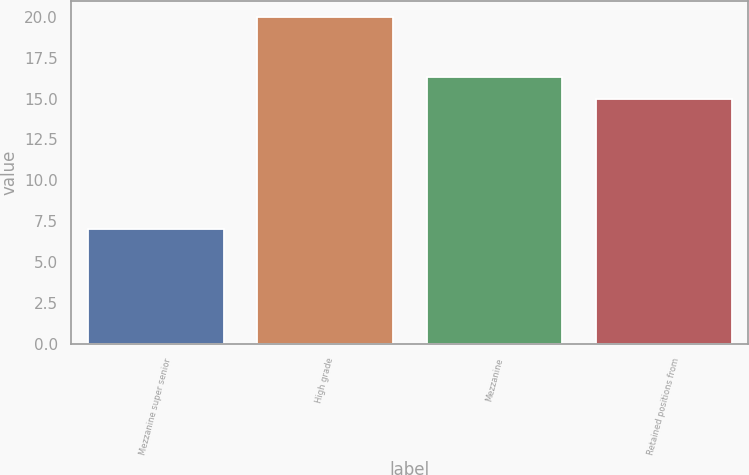<chart> <loc_0><loc_0><loc_500><loc_500><bar_chart><fcel>Mezzanine super senior<fcel>High grade<fcel>Mezzanine<fcel>Retained positions from<nl><fcel>7<fcel>20<fcel>16.3<fcel>15<nl></chart> 